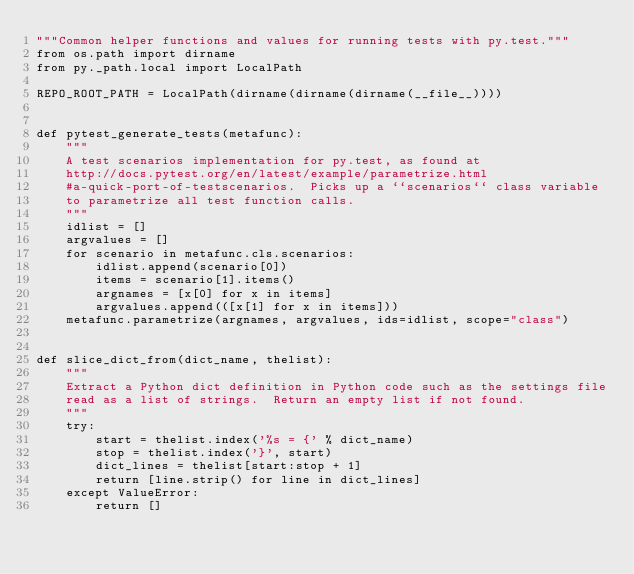<code> <loc_0><loc_0><loc_500><loc_500><_Python_>"""Common helper functions and values for running tests with py.test."""
from os.path import dirname
from py._path.local import LocalPath

REPO_ROOT_PATH = LocalPath(dirname(dirname(dirname(__file__))))


def pytest_generate_tests(metafunc):
    """
    A test scenarios implementation for py.test, as found at
    http://docs.pytest.org/en/latest/example/parametrize.html
    #a-quick-port-of-testscenarios.  Picks up a ``scenarios`` class variable
    to parametrize all test function calls.
    """
    idlist = []
    argvalues = []
    for scenario in metafunc.cls.scenarios:
        idlist.append(scenario[0])
        items = scenario[1].items()
        argnames = [x[0] for x in items]
        argvalues.append(([x[1] for x in items]))
    metafunc.parametrize(argnames, argvalues, ids=idlist, scope="class")


def slice_dict_from(dict_name, thelist):
    """
    Extract a Python dict definition in Python code such as the settings file
    read as a list of strings.  Return an empty list if not found.
    """
    try:
        start = thelist.index('%s = {' % dict_name)
        stop = thelist.index('}', start)
        dict_lines = thelist[start:stop + 1]
        return [line.strip() for line in dict_lines]
    except ValueError:
        return []
</code> 